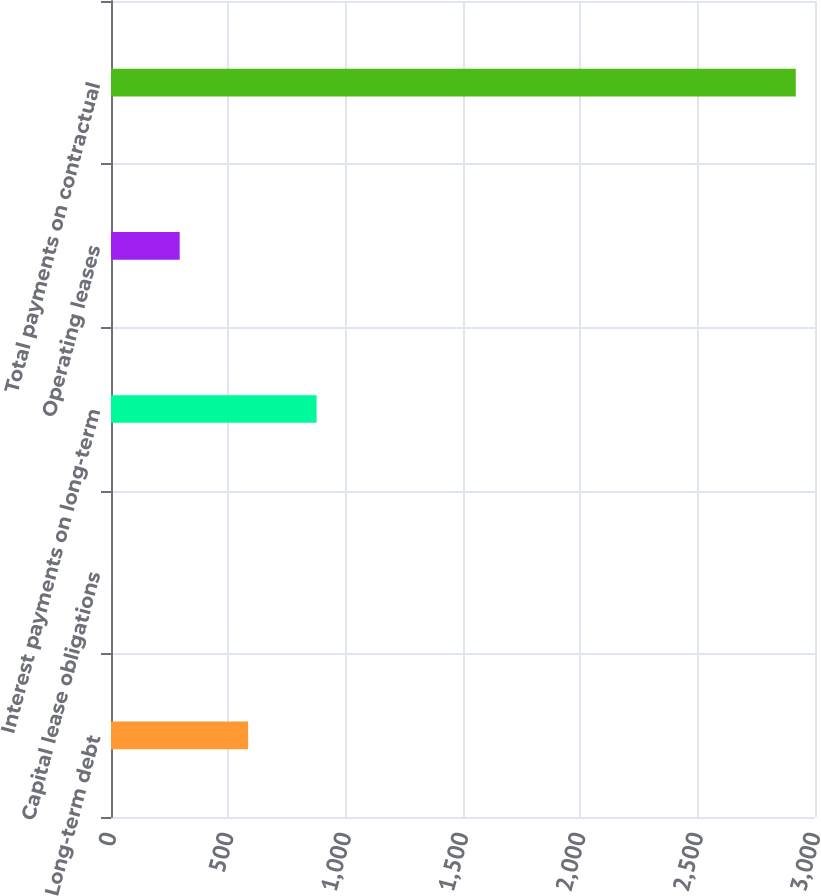Convert chart to OTSL. <chart><loc_0><loc_0><loc_500><loc_500><bar_chart><fcel>Long-term debt<fcel>Capital lease obligations<fcel>Interest payments on long-term<fcel>Operating leases<fcel>Total payments on contractual<nl><fcel>584.42<fcel>1<fcel>876.13<fcel>292.71<fcel>2918.1<nl></chart> 